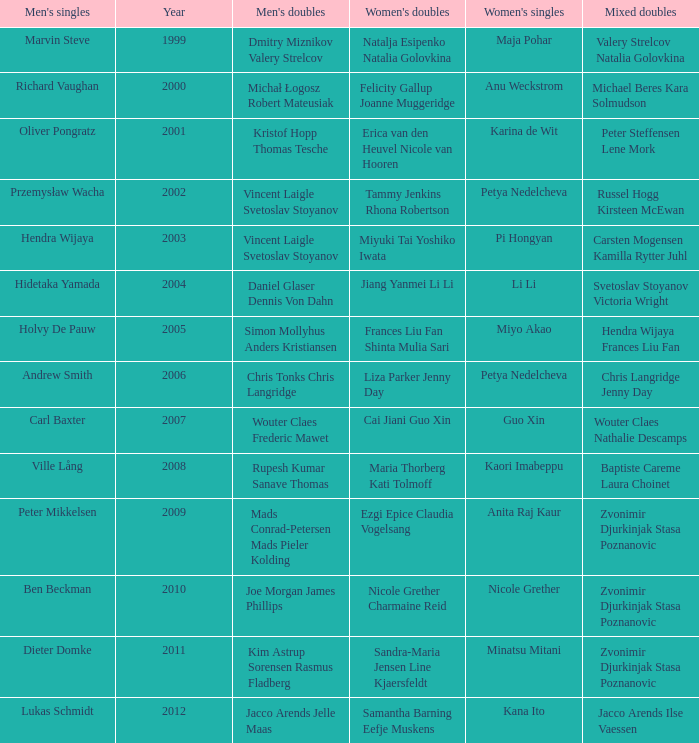What's the first year that Guo Xin featured in women's singles? 2007.0. 